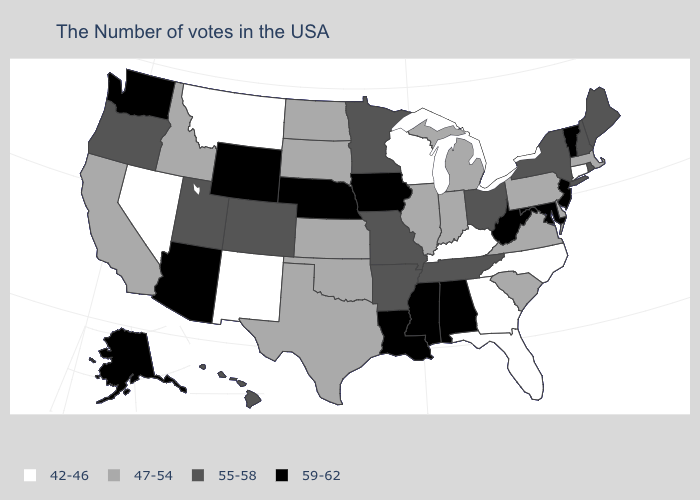Among the states that border Iowa , which have the lowest value?
Give a very brief answer. Wisconsin. Name the states that have a value in the range 42-46?
Keep it brief. Connecticut, North Carolina, Florida, Georgia, Kentucky, Wisconsin, New Mexico, Montana, Nevada. Does New Hampshire have a higher value than Vermont?
Keep it brief. No. What is the value of South Dakota?
Short answer required. 47-54. Which states hav the highest value in the Northeast?
Concise answer only. Vermont, New Jersey. What is the value of New Mexico?
Short answer required. 42-46. What is the value of Vermont?
Short answer required. 59-62. Name the states that have a value in the range 59-62?
Write a very short answer. Vermont, New Jersey, Maryland, West Virginia, Alabama, Mississippi, Louisiana, Iowa, Nebraska, Wyoming, Arizona, Washington, Alaska. Does Maine have a higher value than New Hampshire?
Answer briefly. No. Does Delaware have the highest value in the South?
Short answer required. No. What is the value of California?
Quick response, please. 47-54. Does Nevada have the lowest value in the USA?
Be succinct. Yes. Name the states that have a value in the range 47-54?
Short answer required. Massachusetts, Delaware, Pennsylvania, Virginia, South Carolina, Michigan, Indiana, Illinois, Kansas, Oklahoma, Texas, South Dakota, North Dakota, Idaho, California. How many symbols are there in the legend?
Be succinct. 4. What is the highest value in the Northeast ?
Write a very short answer. 59-62. 